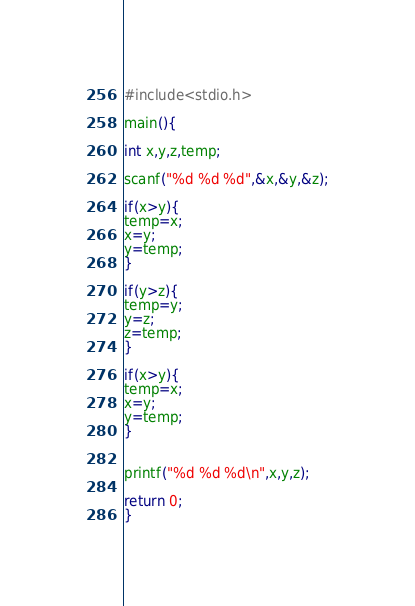<code> <loc_0><loc_0><loc_500><loc_500><_C_>#include<stdio.h>

main(){

int x,y,z,temp;

scanf("%d %d %d",&x,&y,&z);

if(x>y){
temp=x;
x=y;
y=temp;
}

if(y>z){
temp=y;
y=z;
z=temp;
}

if(x>y){
temp=x;
x=y;
y=temp;
}


printf("%d %d %d\n",x,y,z);

return 0;
}</code> 